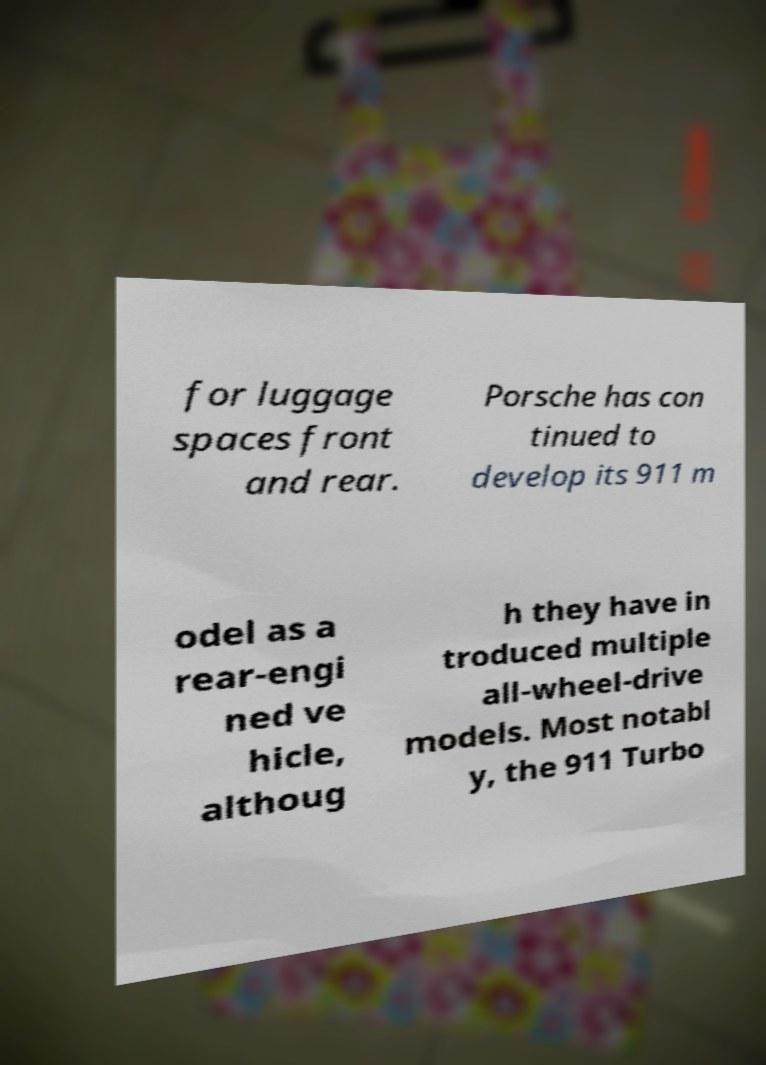There's text embedded in this image that I need extracted. Can you transcribe it verbatim? for luggage spaces front and rear. Porsche has con tinued to develop its 911 m odel as a rear-engi ned ve hicle, althoug h they have in troduced multiple all-wheel-drive models. Most notabl y, the 911 Turbo 